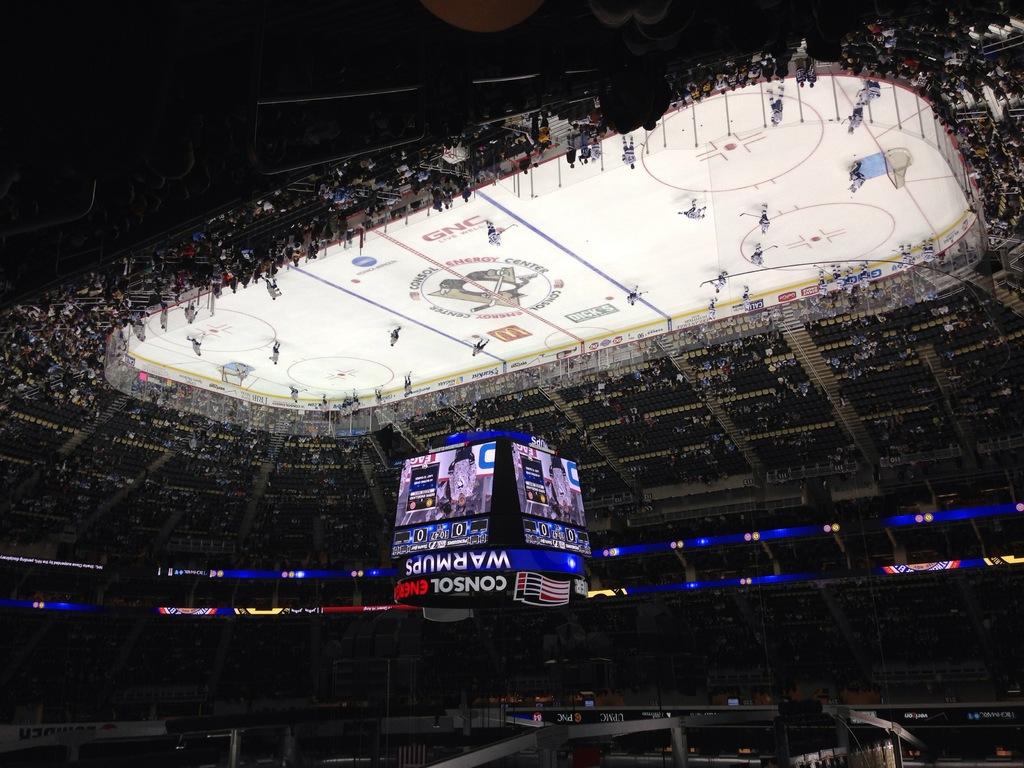What arena are they playing at?
Offer a terse response. Consol energy center. What fast food logo is on the ice?
Offer a very short reply. Mcdonalds. 